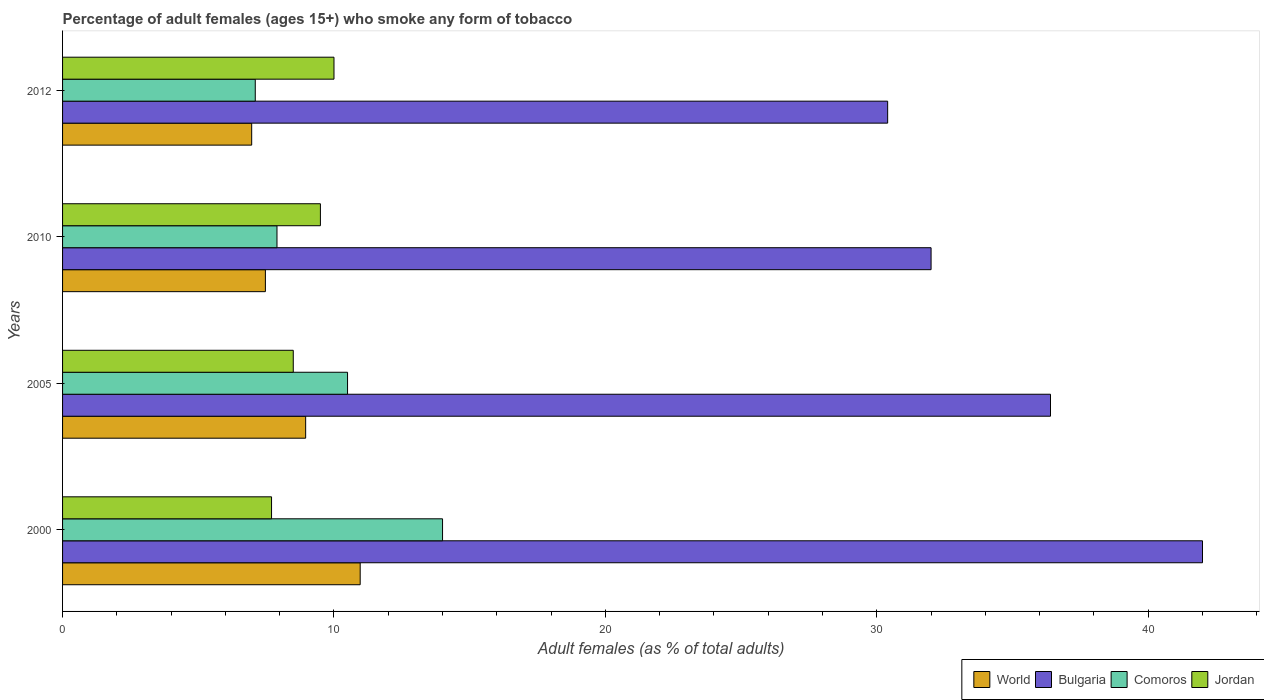Are the number of bars per tick equal to the number of legend labels?
Offer a terse response. Yes. Are the number of bars on each tick of the Y-axis equal?
Offer a very short reply. Yes. How many bars are there on the 1st tick from the top?
Make the answer very short. 4. How many bars are there on the 4th tick from the bottom?
Ensure brevity in your answer.  4. In how many cases, is the number of bars for a given year not equal to the number of legend labels?
Your answer should be very brief. 0. Across all years, what is the maximum percentage of adult females who smoke in Comoros?
Your answer should be very brief. 14. Across all years, what is the minimum percentage of adult females who smoke in Comoros?
Offer a terse response. 7.1. In which year was the percentage of adult females who smoke in Comoros maximum?
Your response must be concise. 2000. What is the total percentage of adult females who smoke in Jordan in the graph?
Provide a short and direct response. 35.7. What is the difference between the percentage of adult females who smoke in Jordan in 2005 and that in 2010?
Make the answer very short. -1. What is the difference between the percentage of adult females who smoke in World in 2005 and the percentage of adult females who smoke in Jordan in 2012?
Your response must be concise. -1.04. What is the average percentage of adult females who smoke in Bulgaria per year?
Give a very brief answer. 35.2. In the year 2005, what is the difference between the percentage of adult females who smoke in World and percentage of adult females who smoke in Bulgaria?
Your answer should be very brief. -27.44. What is the ratio of the percentage of adult females who smoke in Jordan in 2000 to that in 2012?
Make the answer very short. 0.77. Is the difference between the percentage of adult females who smoke in World in 2000 and 2010 greater than the difference between the percentage of adult females who smoke in Bulgaria in 2000 and 2010?
Offer a very short reply. No. What is the difference between the highest and the second highest percentage of adult females who smoke in World?
Provide a short and direct response. 2.01. What is the difference between the highest and the lowest percentage of adult females who smoke in Jordan?
Offer a terse response. 2.3. Is the sum of the percentage of adult females who smoke in Jordan in 2000 and 2010 greater than the maximum percentage of adult females who smoke in Comoros across all years?
Keep it short and to the point. Yes. Is it the case that in every year, the sum of the percentage of adult females who smoke in World and percentage of adult females who smoke in Comoros is greater than the sum of percentage of adult females who smoke in Jordan and percentage of adult females who smoke in Bulgaria?
Make the answer very short. No. What does the 1st bar from the top in 2012 represents?
Provide a short and direct response. Jordan. What does the 3rd bar from the bottom in 2012 represents?
Provide a short and direct response. Comoros. Does the graph contain any zero values?
Make the answer very short. No. What is the title of the graph?
Make the answer very short. Percentage of adult females (ages 15+) who smoke any form of tobacco. What is the label or title of the X-axis?
Give a very brief answer. Adult females (as % of total adults). What is the label or title of the Y-axis?
Provide a succinct answer. Years. What is the Adult females (as % of total adults) in World in 2000?
Keep it short and to the point. 10.97. What is the Adult females (as % of total adults) of Jordan in 2000?
Your answer should be very brief. 7.7. What is the Adult females (as % of total adults) in World in 2005?
Provide a succinct answer. 8.96. What is the Adult females (as % of total adults) in Bulgaria in 2005?
Provide a short and direct response. 36.4. What is the Adult females (as % of total adults) of Comoros in 2005?
Give a very brief answer. 10.5. What is the Adult females (as % of total adults) of Jordan in 2005?
Make the answer very short. 8.5. What is the Adult females (as % of total adults) in World in 2010?
Offer a very short reply. 7.47. What is the Adult females (as % of total adults) of Comoros in 2010?
Your response must be concise. 7.9. What is the Adult females (as % of total adults) of Jordan in 2010?
Ensure brevity in your answer.  9.5. What is the Adult females (as % of total adults) of World in 2012?
Your answer should be very brief. 6.97. What is the Adult females (as % of total adults) in Bulgaria in 2012?
Provide a succinct answer. 30.4. What is the Adult females (as % of total adults) in Jordan in 2012?
Your response must be concise. 10. Across all years, what is the maximum Adult females (as % of total adults) in World?
Your response must be concise. 10.97. Across all years, what is the maximum Adult females (as % of total adults) in Bulgaria?
Keep it short and to the point. 42. Across all years, what is the minimum Adult females (as % of total adults) in World?
Offer a very short reply. 6.97. Across all years, what is the minimum Adult females (as % of total adults) of Bulgaria?
Offer a terse response. 30.4. Across all years, what is the minimum Adult females (as % of total adults) in Comoros?
Provide a short and direct response. 7.1. What is the total Adult females (as % of total adults) in World in the graph?
Your answer should be compact. 34.36. What is the total Adult females (as % of total adults) of Bulgaria in the graph?
Give a very brief answer. 140.8. What is the total Adult females (as % of total adults) in Comoros in the graph?
Your response must be concise. 39.5. What is the total Adult females (as % of total adults) of Jordan in the graph?
Your response must be concise. 35.7. What is the difference between the Adult females (as % of total adults) of World in 2000 and that in 2005?
Make the answer very short. 2.01. What is the difference between the Adult females (as % of total adults) in Bulgaria in 2000 and that in 2005?
Make the answer very short. 5.6. What is the difference between the Adult females (as % of total adults) of Comoros in 2000 and that in 2005?
Your answer should be very brief. 3.5. What is the difference between the Adult females (as % of total adults) in Jordan in 2000 and that in 2005?
Offer a very short reply. -0.8. What is the difference between the Adult females (as % of total adults) in World in 2000 and that in 2010?
Keep it short and to the point. 3.49. What is the difference between the Adult females (as % of total adults) in Bulgaria in 2000 and that in 2010?
Keep it short and to the point. 10. What is the difference between the Adult females (as % of total adults) in Comoros in 2000 and that in 2010?
Your response must be concise. 6.1. What is the difference between the Adult females (as % of total adults) in World in 2000 and that in 2012?
Your answer should be very brief. 4. What is the difference between the Adult females (as % of total adults) in World in 2005 and that in 2010?
Ensure brevity in your answer.  1.48. What is the difference between the Adult females (as % of total adults) of Bulgaria in 2005 and that in 2010?
Your response must be concise. 4.4. What is the difference between the Adult females (as % of total adults) of Comoros in 2005 and that in 2010?
Give a very brief answer. 2.6. What is the difference between the Adult females (as % of total adults) of World in 2005 and that in 2012?
Give a very brief answer. 1.99. What is the difference between the Adult females (as % of total adults) of Bulgaria in 2005 and that in 2012?
Keep it short and to the point. 6. What is the difference between the Adult females (as % of total adults) of Jordan in 2005 and that in 2012?
Your response must be concise. -1.5. What is the difference between the Adult females (as % of total adults) of World in 2010 and that in 2012?
Provide a succinct answer. 0.51. What is the difference between the Adult females (as % of total adults) in Bulgaria in 2010 and that in 2012?
Offer a very short reply. 1.6. What is the difference between the Adult females (as % of total adults) of World in 2000 and the Adult females (as % of total adults) of Bulgaria in 2005?
Provide a succinct answer. -25.43. What is the difference between the Adult females (as % of total adults) in World in 2000 and the Adult females (as % of total adults) in Comoros in 2005?
Make the answer very short. 0.47. What is the difference between the Adult females (as % of total adults) of World in 2000 and the Adult females (as % of total adults) of Jordan in 2005?
Make the answer very short. 2.47. What is the difference between the Adult females (as % of total adults) in Bulgaria in 2000 and the Adult females (as % of total adults) in Comoros in 2005?
Provide a short and direct response. 31.5. What is the difference between the Adult females (as % of total adults) of Bulgaria in 2000 and the Adult females (as % of total adults) of Jordan in 2005?
Provide a succinct answer. 33.5. What is the difference between the Adult females (as % of total adults) of World in 2000 and the Adult females (as % of total adults) of Bulgaria in 2010?
Your response must be concise. -21.03. What is the difference between the Adult females (as % of total adults) of World in 2000 and the Adult females (as % of total adults) of Comoros in 2010?
Provide a short and direct response. 3.07. What is the difference between the Adult females (as % of total adults) of World in 2000 and the Adult females (as % of total adults) of Jordan in 2010?
Give a very brief answer. 1.47. What is the difference between the Adult females (as % of total adults) in Bulgaria in 2000 and the Adult females (as % of total adults) in Comoros in 2010?
Offer a very short reply. 34.1. What is the difference between the Adult females (as % of total adults) in Bulgaria in 2000 and the Adult females (as % of total adults) in Jordan in 2010?
Give a very brief answer. 32.5. What is the difference between the Adult females (as % of total adults) in World in 2000 and the Adult females (as % of total adults) in Bulgaria in 2012?
Your answer should be very brief. -19.43. What is the difference between the Adult females (as % of total adults) in World in 2000 and the Adult females (as % of total adults) in Comoros in 2012?
Make the answer very short. 3.87. What is the difference between the Adult females (as % of total adults) in World in 2000 and the Adult females (as % of total adults) in Jordan in 2012?
Your response must be concise. 0.97. What is the difference between the Adult females (as % of total adults) of Bulgaria in 2000 and the Adult females (as % of total adults) of Comoros in 2012?
Provide a succinct answer. 34.9. What is the difference between the Adult females (as % of total adults) of Bulgaria in 2000 and the Adult females (as % of total adults) of Jordan in 2012?
Give a very brief answer. 32. What is the difference between the Adult females (as % of total adults) of World in 2005 and the Adult females (as % of total adults) of Bulgaria in 2010?
Offer a very short reply. -23.04. What is the difference between the Adult females (as % of total adults) in World in 2005 and the Adult females (as % of total adults) in Comoros in 2010?
Provide a succinct answer. 1.06. What is the difference between the Adult females (as % of total adults) in World in 2005 and the Adult females (as % of total adults) in Jordan in 2010?
Make the answer very short. -0.54. What is the difference between the Adult females (as % of total adults) of Bulgaria in 2005 and the Adult females (as % of total adults) of Comoros in 2010?
Your answer should be very brief. 28.5. What is the difference between the Adult females (as % of total adults) of Bulgaria in 2005 and the Adult females (as % of total adults) of Jordan in 2010?
Offer a terse response. 26.9. What is the difference between the Adult females (as % of total adults) of World in 2005 and the Adult females (as % of total adults) of Bulgaria in 2012?
Your response must be concise. -21.44. What is the difference between the Adult females (as % of total adults) of World in 2005 and the Adult females (as % of total adults) of Comoros in 2012?
Your response must be concise. 1.86. What is the difference between the Adult females (as % of total adults) of World in 2005 and the Adult females (as % of total adults) of Jordan in 2012?
Make the answer very short. -1.04. What is the difference between the Adult females (as % of total adults) in Bulgaria in 2005 and the Adult females (as % of total adults) in Comoros in 2012?
Provide a short and direct response. 29.3. What is the difference between the Adult females (as % of total adults) in Bulgaria in 2005 and the Adult females (as % of total adults) in Jordan in 2012?
Provide a succinct answer. 26.4. What is the difference between the Adult females (as % of total adults) in Comoros in 2005 and the Adult females (as % of total adults) in Jordan in 2012?
Your answer should be compact. 0.5. What is the difference between the Adult females (as % of total adults) in World in 2010 and the Adult females (as % of total adults) in Bulgaria in 2012?
Offer a very short reply. -22.93. What is the difference between the Adult females (as % of total adults) in World in 2010 and the Adult females (as % of total adults) in Comoros in 2012?
Make the answer very short. 0.37. What is the difference between the Adult females (as % of total adults) in World in 2010 and the Adult females (as % of total adults) in Jordan in 2012?
Ensure brevity in your answer.  -2.53. What is the difference between the Adult females (as % of total adults) of Bulgaria in 2010 and the Adult females (as % of total adults) of Comoros in 2012?
Your response must be concise. 24.9. What is the difference between the Adult females (as % of total adults) of Comoros in 2010 and the Adult females (as % of total adults) of Jordan in 2012?
Offer a terse response. -2.1. What is the average Adult females (as % of total adults) in World per year?
Ensure brevity in your answer.  8.59. What is the average Adult females (as % of total adults) of Bulgaria per year?
Ensure brevity in your answer.  35.2. What is the average Adult females (as % of total adults) of Comoros per year?
Provide a short and direct response. 9.88. What is the average Adult females (as % of total adults) of Jordan per year?
Keep it short and to the point. 8.93. In the year 2000, what is the difference between the Adult females (as % of total adults) of World and Adult females (as % of total adults) of Bulgaria?
Ensure brevity in your answer.  -31.03. In the year 2000, what is the difference between the Adult females (as % of total adults) in World and Adult females (as % of total adults) in Comoros?
Provide a succinct answer. -3.03. In the year 2000, what is the difference between the Adult females (as % of total adults) in World and Adult females (as % of total adults) in Jordan?
Keep it short and to the point. 3.27. In the year 2000, what is the difference between the Adult females (as % of total adults) of Bulgaria and Adult females (as % of total adults) of Comoros?
Keep it short and to the point. 28. In the year 2000, what is the difference between the Adult females (as % of total adults) of Bulgaria and Adult females (as % of total adults) of Jordan?
Give a very brief answer. 34.3. In the year 2005, what is the difference between the Adult females (as % of total adults) in World and Adult females (as % of total adults) in Bulgaria?
Your response must be concise. -27.44. In the year 2005, what is the difference between the Adult females (as % of total adults) in World and Adult females (as % of total adults) in Comoros?
Make the answer very short. -1.54. In the year 2005, what is the difference between the Adult females (as % of total adults) of World and Adult females (as % of total adults) of Jordan?
Keep it short and to the point. 0.46. In the year 2005, what is the difference between the Adult females (as % of total adults) of Bulgaria and Adult females (as % of total adults) of Comoros?
Your answer should be compact. 25.9. In the year 2005, what is the difference between the Adult females (as % of total adults) of Bulgaria and Adult females (as % of total adults) of Jordan?
Your answer should be very brief. 27.9. In the year 2005, what is the difference between the Adult females (as % of total adults) of Comoros and Adult females (as % of total adults) of Jordan?
Provide a succinct answer. 2. In the year 2010, what is the difference between the Adult females (as % of total adults) of World and Adult females (as % of total adults) of Bulgaria?
Ensure brevity in your answer.  -24.53. In the year 2010, what is the difference between the Adult females (as % of total adults) of World and Adult females (as % of total adults) of Comoros?
Offer a terse response. -0.43. In the year 2010, what is the difference between the Adult females (as % of total adults) of World and Adult females (as % of total adults) of Jordan?
Provide a succinct answer. -2.03. In the year 2010, what is the difference between the Adult females (as % of total adults) in Bulgaria and Adult females (as % of total adults) in Comoros?
Offer a very short reply. 24.1. In the year 2010, what is the difference between the Adult females (as % of total adults) of Bulgaria and Adult females (as % of total adults) of Jordan?
Provide a succinct answer. 22.5. In the year 2012, what is the difference between the Adult females (as % of total adults) in World and Adult females (as % of total adults) in Bulgaria?
Offer a terse response. -23.43. In the year 2012, what is the difference between the Adult females (as % of total adults) in World and Adult females (as % of total adults) in Comoros?
Offer a very short reply. -0.13. In the year 2012, what is the difference between the Adult females (as % of total adults) in World and Adult females (as % of total adults) in Jordan?
Offer a very short reply. -3.03. In the year 2012, what is the difference between the Adult females (as % of total adults) of Bulgaria and Adult females (as % of total adults) of Comoros?
Provide a short and direct response. 23.3. In the year 2012, what is the difference between the Adult females (as % of total adults) in Bulgaria and Adult females (as % of total adults) in Jordan?
Provide a short and direct response. 20.4. In the year 2012, what is the difference between the Adult females (as % of total adults) of Comoros and Adult females (as % of total adults) of Jordan?
Your response must be concise. -2.9. What is the ratio of the Adult females (as % of total adults) of World in 2000 to that in 2005?
Your answer should be very brief. 1.22. What is the ratio of the Adult females (as % of total adults) in Bulgaria in 2000 to that in 2005?
Your answer should be very brief. 1.15. What is the ratio of the Adult females (as % of total adults) of Jordan in 2000 to that in 2005?
Give a very brief answer. 0.91. What is the ratio of the Adult females (as % of total adults) in World in 2000 to that in 2010?
Your response must be concise. 1.47. What is the ratio of the Adult females (as % of total adults) of Bulgaria in 2000 to that in 2010?
Give a very brief answer. 1.31. What is the ratio of the Adult females (as % of total adults) of Comoros in 2000 to that in 2010?
Offer a very short reply. 1.77. What is the ratio of the Adult females (as % of total adults) in Jordan in 2000 to that in 2010?
Offer a very short reply. 0.81. What is the ratio of the Adult females (as % of total adults) in World in 2000 to that in 2012?
Your response must be concise. 1.57. What is the ratio of the Adult females (as % of total adults) of Bulgaria in 2000 to that in 2012?
Your answer should be very brief. 1.38. What is the ratio of the Adult females (as % of total adults) of Comoros in 2000 to that in 2012?
Ensure brevity in your answer.  1.97. What is the ratio of the Adult females (as % of total adults) in Jordan in 2000 to that in 2012?
Your response must be concise. 0.77. What is the ratio of the Adult females (as % of total adults) in World in 2005 to that in 2010?
Provide a succinct answer. 1.2. What is the ratio of the Adult females (as % of total adults) in Bulgaria in 2005 to that in 2010?
Provide a short and direct response. 1.14. What is the ratio of the Adult females (as % of total adults) in Comoros in 2005 to that in 2010?
Keep it short and to the point. 1.33. What is the ratio of the Adult females (as % of total adults) in Jordan in 2005 to that in 2010?
Give a very brief answer. 0.89. What is the ratio of the Adult females (as % of total adults) in World in 2005 to that in 2012?
Your answer should be compact. 1.29. What is the ratio of the Adult females (as % of total adults) in Bulgaria in 2005 to that in 2012?
Your answer should be compact. 1.2. What is the ratio of the Adult females (as % of total adults) in Comoros in 2005 to that in 2012?
Make the answer very short. 1.48. What is the ratio of the Adult females (as % of total adults) of Jordan in 2005 to that in 2012?
Provide a short and direct response. 0.85. What is the ratio of the Adult females (as % of total adults) in World in 2010 to that in 2012?
Provide a succinct answer. 1.07. What is the ratio of the Adult females (as % of total adults) of Bulgaria in 2010 to that in 2012?
Ensure brevity in your answer.  1.05. What is the ratio of the Adult females (as % of total adults) of Comoros in 2010 to that in 2012?
Your answer should be compact. 1.11. What is the ratio of the Adult females (as % of total adults) in Jordan in 2010 to that in 2012?
Provide a short and direct response. 0.95. What is the difference between the highest and the second highest Adult females (as % of total adults) in World?
Offer a terse response. 2.01. What is the difference between the highest and the second highest Adult females (as % of total adults) in Bulgaria?
Provide a succinct answer. 5.6. What is the difference between the highest and the second highest Adult females (as % of total adults) in Comoros?
Give a very brief answer. 3.5. What is the difference between the highest and the lowest Adult females (as % of total adults) in World?
Your answer should be compact. 4. What is the difference between the highest and the lowest Adult females (as % of total adults) of Jordan?
Keep it short and to the point. 2.3. 